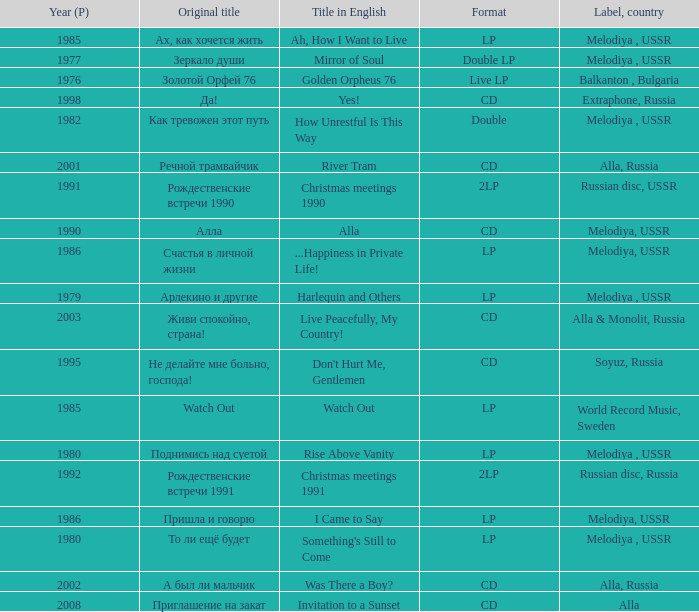What is the english title with a lp format and an Original title of то ли ещё будет? Something's Still to Come. 